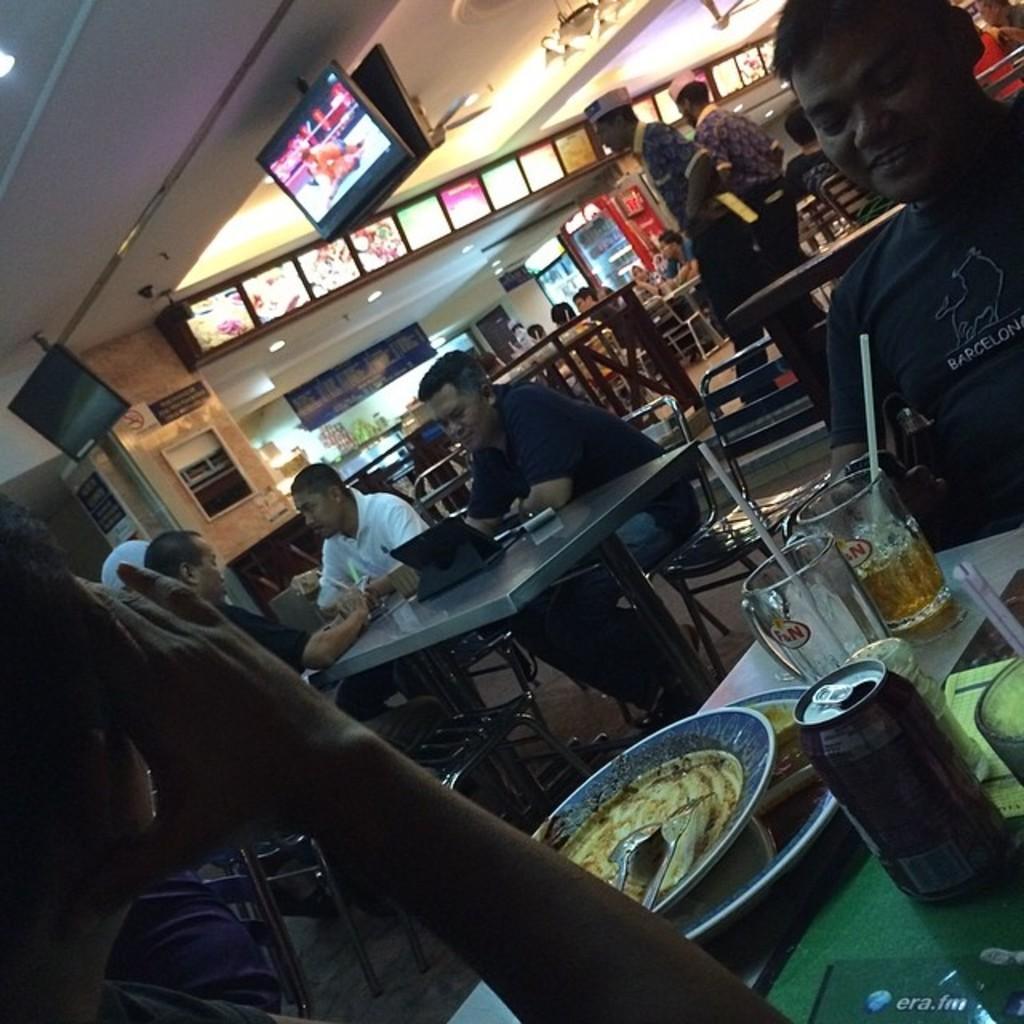Can you describe this image briefly? In this image there are few persons visible in front of table and there are some chairs visible in front of table, on the table there is a plate ,coke tin glasses and straws visible, on the right side at the top there is a roof , on the roof there are some fans , lights, visible. 